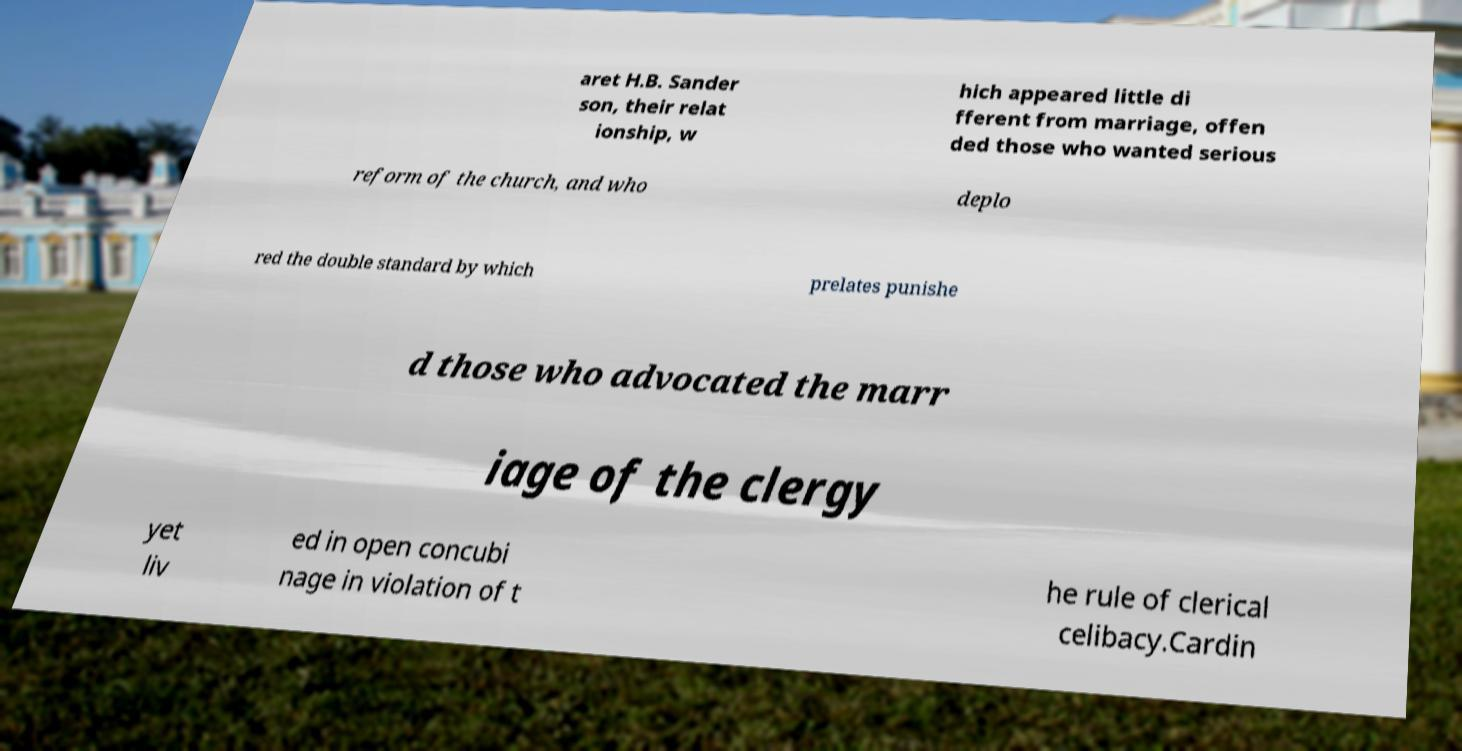Can you accurately transcribe the text from the provided image for me? aret H.B. Sander son, their relat ionship, w hich appeared little di fferent from marriage, offen ded those who wanted serious reform of the church, and who deplo red the double standard by which prelates punishe d those who advocated the marr iage of the clergy yet liv ed in open concubi nage in violation of t he rule of clerical celibacy.Cardin 